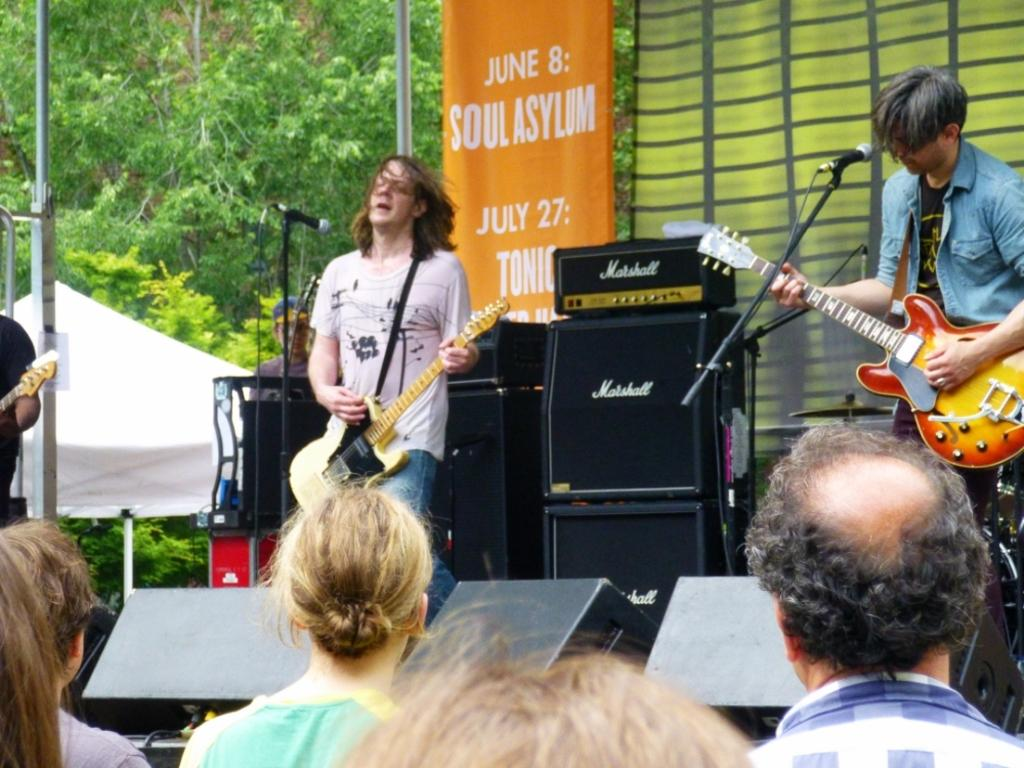What type of event is depicted in the image? The image is from a concert. What instruments are the two men playing? The two men are playing guitar. What is behind the men that amplifies the sound? There are speakers behind the men. What can be seen to the left of the image? There are trees and a tent to the left of the image. What type of collar can be seen on the frog in the image? There is no frog present in the image, and therefore no collar can be observed. 